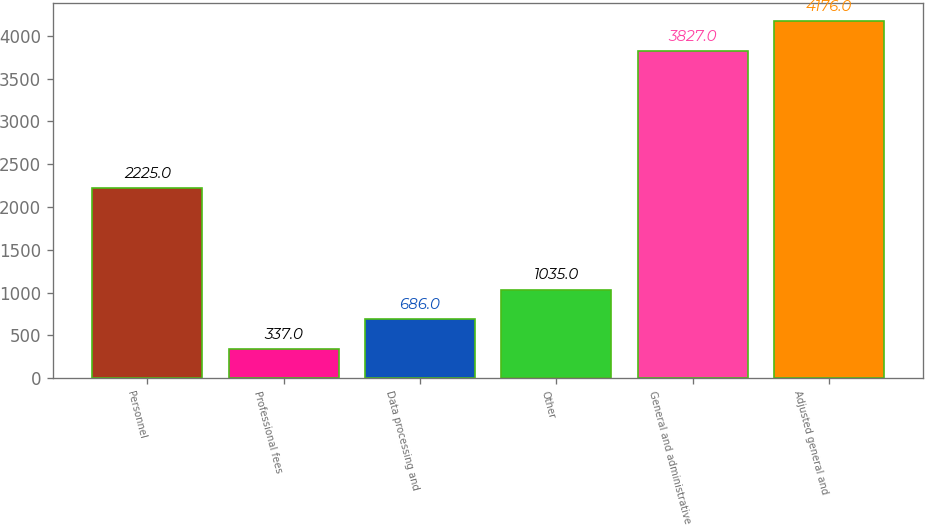Convert chart. <chart><loc_0><loc_0><loc_500><loc_500><bar_chart><fcel>Personnel<fcel>Professional fees<fcel>Data processing and<fcel>Other<fcel>General and administrative<fcel>Adjusted general and<nl><fcel>2225<fcel>337<fcel>686<fcel>1035<fcel>3827<fcel>4176<nl></chart> 